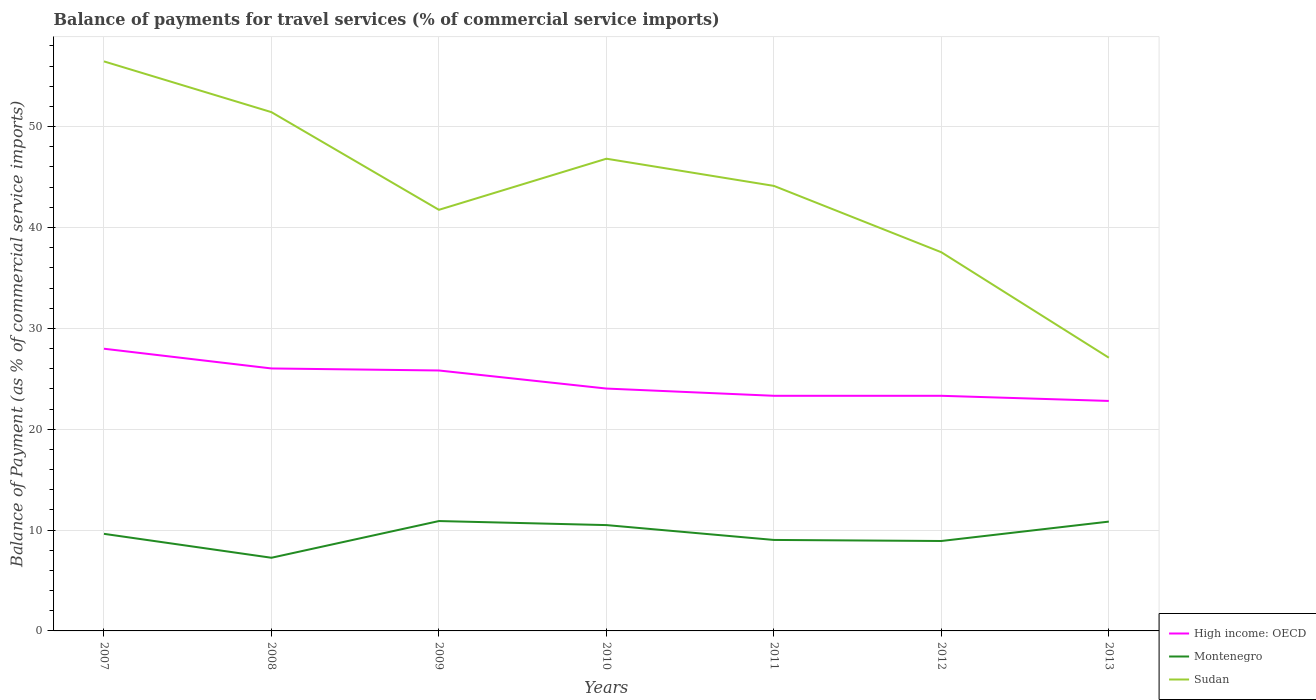How many different coloured lines are there?
Offer a very short reply. 3. Is the number of lines equal to the number of legend labels?
Your answer should be compact. Yes. Across all years, what is the maximum balance of payments for travel services in Sudan?
Provide a short and direct response. 27.09. In which year was the balance of payments for travel services in Sudan maximum?
Keep it short and to the point. 2013. What is the total balance of payments for travel services in Sudan in the graph?
Your answer should be compact. 19.73. What is the difference between the highest and the second highest balance of payments for travel services in High income: OECD?
Offer a terse response. 5.18. What is the difference between the highest and the lowest balance of payments for travel services in High income: OECD?
Provide a succinct answer. 3. Is the balance of payments for travel services in High income: OECD strictly greater than the balance of payments for travel services in Montenegro over the years?
Make the answer very short. No. How many years are there in the graph?
Your answer should be very brief. 7. Are the values on the major ticks of Y-axis written in scientific E-notation?
Provide a short and direct response. No. How many legend labels are there?
Provide a succinct answer. 3. What is the title of the graph?
Keep it short and to the point. Balance of payments for travel services (% of commercial service imports). Does "Vanuatu" appear as one of the legend labels in the graph?
Give a very brief answer. No. What is the label or title of the Y-axis?
Provide a short and direct response. Balance of Payment (as % of commercial service imports). What is the Balance of Payment (as % of commercial service imports) in High income: OECD in 2007?
Offer a very short reply. 27.98. What is the Balance of Payment (as % of commercial service imports) in Montenegro in 2007?
Offer a terse response. 9.63. What is the Balance of Payment (as % of commercial service imports) of Sudan in 2007?
Ensure brevity in your answer.  56.47. What is the Balance of Payment (as % of commercial service imports) of High income: OECD in 2008?
Provide a short and direct response. 26.02. What is the Balance of Payment (as % of commercial service imports) in Montenegro in 2008?
Offer a very short reply. 7.25. What is the Balance of Payment (as % of commercial service imports) in Sudan in 2008?
Offer a very short reply. 51.44. What is the Balance of Payment (as % of commercial service imports) of High income: OECD in 2009?
Offer a terse response. 25.82. What is the Balance of Payment (as % of commercial service imports) in Montenegro in 2009?
Make the answer very short. 10.89. What is the Balance of Payment (as % of commercial service imports) in Sudan in 2009?
Make the answer very short. 41.75. What is the Balance of Payment (as % of commercial service imports) of High income: OECD in 2010?
Give a very brief answer. 24.03. What is the Balance of Payment (as % of commercial service imports) of Montenegro in 2010?
Your answer should be very brief. 10.49. What is the Balance of Payment (as % of commercial service imports) of Sudan in 2010?
Ensure brevity in your answer.  46.82. What is the Balance of Payment (as % of commercial service imports) in High income: OECD in 2011?
Provide a short and direct response. 23.31. What is the Balance of Payment (as % of commercial service imports) in Montenegro in 2011?
Your answer should be compact. 9.02. What is the Balance of Payment (as % of commercial service imports) in Sudan in 2011?
Keep it short and to the point. 44.13. What is the Balance of Payment (as % of commercial service imports) of High income: OECD in 2012?
Make the answer very short. 23.31. What is the Balance of Payment (as % of commercial service imports) of Montenegro in 2012?
Your response must be concise. 8.92. What is the Balance of Payment (as % of commercial service imports) in Sudan in 2012?
Offer a terse response. 37.54. What is the Balance of Payment (as % of commercial service imports) of High income: OECD in 2013?
Your response must be concise. 22.8. What is the Balance of Payment (as % of commercial service imports) in Montenegro in 2013?
Offer a very short reply. 10.84. What is the Balance of Payment (as % of commercial service imports) of Sudan in 2013?
Your answer should be compact. 27.09. Across all years, what is the maximum Balance of Payment (as % of commercial service imports) of High income: OECD?
Provide a succinct answer. 27.98. Across all years, what is the maximum Balance of Payment (as % of commercial service imports) in Montenegro?
Your response must be concise. 10.89. Across all years, what is the maximum Balance of Payment (as % of commercial service imports) of Sudan?
Your response must be concise. 56.47. Across all years, what is the minimum Balance of Payment (as % of commercial service imports) in High income: OECD?
Offer a terse response. 22.8. Across all years, what is the minimum Balance of Payment (as % of commercial service imports) of Montenegro?
Ensure brevity in your answer.  7.25. Across all years, what is the minimum Balance of Payment (as % of commercial service imports) in Sudan?
Make the answer very short. 27.09. What is the total Balance of Payment (as % of commercial service imports) of High income: OECD in the graph?
Your answer should be very brief. 173.29. What is the total Balance of Payment (as % of commercial service imports) of Montenegro in the graph?
Your answer should be compact. 67.04. What is the total Balance of Payment (as % of commercial service imports) of Sudan in the graph?
Ensure brevity in your answer.  305.24. What is the difference between the Balance of Payment (as % of commercial service imports) in High income: OECD in 2007 and that in 2008?
Make the answer very short. 1.96. What is the difference between the Balance of Payment (as % of commercial service imports) of Montenegro in 2007 and that in 2008?
Your answer should be compact. 2.37. What is the difference between the Balance of Payment (as % of commercial service imports) of Sudan in 2007 and that in 2008?
Your answer should be compact. 5.03. What is the difference between the Balance of Payment (as % of commercial service imports) in High income: OECD in 2007 and that in 2009?
Your response must be concise. 2.16. What is the difference between the Balance of Payment (as % of commercial service imports) in Montenegro in 2007 and that in 2009?
Your response must be concise. -1.27. What is the difference between the Balance of Payment (as % of commercial service imports) in Sudan in 2007 and that in 2009?
Give a very brief answer. 14.72. What is the difference between the Balance of Payment (as % of commercial service imports) of High income: OECD in 2007 and that in 2010?
Offer a very short reply. 3.95. What is the difference between the Balance of Payment (as % of commercial service imports) in Montenegro in 2007 and that in 2010?
Your answer should be compact. -0.87. What is the difference between the Balance of Payment (as % of commercial service imports) of Sudan in 2007 and that in 2010?
Make the answer very short. 9.65. What is the difference between the Balance of Payment (as % of commercial service imports) in High income: OECD in 2007 and that in 2011?
Your response must be concise. 4.67. What is the difference between the Balance of Payment (as % of commercial service imports) in Montenegro in 2007 and that in 2011?
Make the answer very short. 0.61. What is the difference between the Balance of Payment (as % of commercial service imports) of Sudan in 2007 and that in 2011?
Offer a very short reply. 12.34. What is the difference between the Balance of Payment (as % of commercial service imports) of High income: OECD in 2007 and that in 2012?
Provide a succinct answer. 4.67. What is the difference between the Balance of Payment (as % of commercial service imports) of Montenegro in 2007 and that in 2012?
Offer a terse response. 0.71. What is the difference between the Balance of Payment (as % of commercial service imports) of Sudan in 2007 and that in 2012?
Ensure brevity in your answer.  18.92. What is the difference between the Balance of Payment (as % of commercial service imports) in High income: OECD in 2007 and that in 2013?
Provide a succinct answer. 5.18. What is the difference between the Balance of Payment (as % of commercial service imports) of Montenegro in 2007 and that in 2013?
Provide a succinct answer. -1.21. What is the difference between the Balance of Payment (as % of commercial service imports) of Sudan in 2007 and that in 2013?
Offer a terse response. 29.38. What is the difference between the Balance of Payment (as % of commercial service imports) in High income: OECD in 2008 and that in 2009?
Make the answer very short. 0.2. What is the difference between the Balance of Payment (as % of commercial service imports) in Montenegro in 2008 and that in 2009?
Your response must be concise. -3.64. What is the difference between the Balance of Payment (as % of commercial service imports) in Sudan in 2008 and that in 2009?
Offer a terse response. 9.68. What is the difference between the Balance of Payment (as % of commercial service imports) of High income: OECD in 2008 and that in 2010?
Your response must be concise. 1.99. What is the difference between the Balance of Payment (as % of commercial service imports) of Montenegro in 2008 and that in 2010?
Provide a succinct answer. -3.24. What is the difference between the Balance of Payment (as % of commercial service imports) of Sudan in 2008 and that in 2010?
Your answer should be compact. 4.62. What is the difference between the Balance of Payment (as % of commercial service imports) in High income: OECD in 2008 and that in 2011?
Provide a succinct answer. 2.71. What is the difference between the Balance of Payment (as % of commercial service imports) of Montenegro in 2008 and that in 2011?
Your answer should be compact. -1.77. What is the difference between the Balance of Payment (as % of commercial service imports) in Sudan in 2008 and that in 2011?
Your answer should be compact. 7.31. What is the difference between the Balance of Payment (as % of commercial service imports) in High income: OECD in 2008 and that in 2012?
Your response must be concise. 2.71. What is the difference between the Balance of Payment (as % of commercial service imports) in Montenegro in 2008 and that in 2012?
Offer a very short reply. -1.66. What is the difference between the Balance of Payment (as % of commercial service imports) of Sudan in 2008 and that in 2012?
Your answer should be very brief. 13.89. What is the difference between the Balance of Payment (as % of commercial service imports) in High income: OECD in 2008 and that in 2013?
Make the answer very short. 3.22. What is the difference between the Balance of Payment (as % of commercial service imports) in Montenegro in 2008 and that in 2013?
Ensure brevity in your answer.  -3.58. What is the difference between the Balance of Payment (as % of commercial service imports) of Sudan in 2008 and that in 2013?
Offer a very short reply. 24.35. What is the difference between the Balance of Payment (as % of commercial service imports) of High income: OECD in 2009 and that in 2010?
Provide a short and direct response. 1.79. What is the difference between the Balance of Payment (as % of commercial service imports) of Montenegro in 2009 and that in 2010?
Offer a very short reply. 0.4. What is the difference between the Balance of Payment (as % of commercial service imports) of Sudan in 2009 and that in 2010?
Keep it short and to the point. -5.07. What is the difference between the Balance of Payment (as % of commercial service imports) in High income: OECD in 2009 and that in 2011?
Give a very brief answer. 2.51. What is the difference between the Balance of Payment (as % of commercial service imports) in Montenegro in 2009 and that in 2011?
Make the answer very short. 1.87. What is the difference between the Balance of Payment (as % of commercial service imports) in Sudan in 2009 and that in 2011?
Provide a succinct answer. -2.37. What is the difference between the Balance of Payment (as % of commercial service imports) in High income: OECD in 2009 and that in 2012?
Keep it short and to the point. 2.51. What is the difference between the Balance of Payment (as % of commercial service imports) in Montenegro in 2009 and that in 2012?
Keep it short and to the point. 1.98. What is the difference between the Balance of Payment (as % of commercial service imports) in Sudan in 2009 and that in 2012?
Ensure brevity in your answer.  4.21. What is the difference between the Balance of Payment (as % of commercial service imports) of High income: OECD in 2009 and that in 2013?
Your response must be concise. 3.02. What is the difference between the Balance of Payment (as % of commercial service imports) in Montenegro in 2009 and that in 2013?
Offer a very short reply. 0.05. What is the difference between the Balance of Payment (as % of commercial service imports) in Sudan in 2009 and that in 2013?
Keep it short and to the point. 14.66. What is the difference between the Balance of Payment (as % of commercial service imports) of High income: OECD in 2010 and that in 2011?
Offer a terse response. 0.72. What is the difference between the Balance of Payment (as % of commercial service imports) in Montenegro in 2010 and that in 2011?
Provide a short and direct response. 1.47. What is the difference between the Balance of Payment (as % of commercial service imports) in Sudan in 2010 and that in 2011?
Give a very brief answer. 2.69. What is the difference between the Balance of Payment (as % of commercial service imports) in High income: OECD in 2010 and that in 2012?
Give a very brief answer. 0.72. What is the difference between the Balance of Payment (as % of commercial service imports) in Montenegro in 2010 and that in 2012?
Your answer should be compact. 1.58. What is the difference between the Balance of Payment (as % of commercial service imports) in Sudan in 2010 and that in 2012?
Your answer should be compact. 9.28. What is the difference between the Balance of Payment (as % of commercial service imports) of High income: OECD in 2010 and that in 2013?
Keep it short and to the point. 1.23. What is the difference between the Balance of Payment (as % of commercial service imports) of Montenegro in 2010 and that in 2013?
Your answer should be very brief. -0.35. What is the difference between the Balance of Payment (as % of commercial service imports) in Sudan in 2010 and that in 2013?
Your answer should be compact. 19.73. What is the difference between the Balance of Payment (as % of commercial service imports) in High income: OECD in 2011 and that in 2012?
Your response must be concise. 0. What is the difference between the Balance of Payment (as % of commercial service imports) of Montenegro in 2011 and that in 2012?
Make the answer very short. 0.1. What is the difference between the Balance of Payment (as % of commercial service imports) in Sudan in 2011 and that in 2012?
Offer a very short reply. 6.58. What is the difference between the Balance of Payment (as % of commercial service imports) in High income: OECD in 2011 and that in 2013?
Make the answer very short. 0.51. What is the difference between the Balance of Payment (as % of commercial service imports) of Montenegro in 2011 and that in 2013?
Offer a very short reply. -1.82. What is the difference between the Balance of Payment (as % of commercial service imports) of Sudan in 2011 and that in 2013?
Provide a succinct answer. 17.04. What is the difference between the Balance of Payment (as % of commercial service imports) of High income: OECD in 2012 and that in 2013?
Your response must be concise. 0.51. What is the difference between the Balance of Payment (as % of commercial service imports) of Montenegro in 2012 and that in 2013?
Provide a succinct answer. -1.92. What is the difference between the Balance of Payment (as % of commercial service imports) of Sudan in 2012 and that in 2013?
Ensure brevity in your answer.  10.45. What is the difference between the Balance of Payment (as % of commercial service imports) in High income: OECD in 2007 and the Balance of Payment (as % of commercial service imports) in Montenegro in 2008?
Your answer should be compact. 20.73. What is the difference between the Balance of Payment (as % of commercial service imports) of High income: OECD in 2007 and the Balance of Payment (as % of commercial service imports) of Sudan in 2008?
Offer a terse response. -23.46. What is the difference between the Balance of Payment (as % of commercial service imports) of Montenegro in 2007 and the Balance of Payment (as % of commercial service imports) of Sudan in 2008?
Offer a terse response. -41.81. What is the difference between the Balance of Payment (as % of commercial service imports) in High income: OECD in 2007 and the Balance of Payment (as % of commercial service imports) in Montenegro in 2009?
Provide a short and direct response. 17.09. What is the difference between the Balance of Payment (as % of commercial service imports) of High income: OECD in 2007 and the Balance of Payment (as % of commercial service imports) of Sudan in 2009?
Make the answer very short. -13.77. What is the difference between the Balance of Payment (as % of commercial service imports) in Montenegro in 2007 and the Balance of Payment (as % of commercial service imports) in Sudan in 2009?
Offer a very short reply. -32.13. What is the difference between the Balance of Payment (as % of commercial service imports) in High income: OECD in 2007 and the Balance of Payment (as % of commercial service imports) in Montenegro in 2010?
Give a very brief answer. 17.49. What is the difference between the Balance of Payment (as % of commercial service imports) of High income: OECD in 2007 and the Balance of Payment (as % of commercial service imports) of Sudan in 2010?
Provide a short and direct response. -18.84. What is the difference between the Balance of Payment (as % of commercial service imports) of Montenegro in 2007 and the Balance of Payment (as % of commercial service imports) of Sudan in 2010?
Your answer should be very brief. -37.19. What is the difference between the Balance of Payment (as % of commercial service imports) of High income: OECD in 2007 and the Balance of Payment (as % of commercial service imports) of Montenegro in 2011?
Keep it short and to the point. 18.96. What is the difference between the Balance of Payment (as % of commercial service imports) in High income: OECD in 2007 and the Balance of Payment (as % of commercial service imports) in Sudan in 2011?
Your answer should be very brief. -16.15. What is the difference between the Balance of Payment (as % of commercial service imports) of Montenegro in 2007 and the Balance of Payment (as % of commercial service imports) of Sudan in 2011?
Ensure brevity in your answer.  -34.5. What is the difference between the Balance of Payment (as % of commercial service imports) of High income: OECD in 2007 and the Balance of Payment (as % of commercial service imports) of Montenegro in 2012?
Your answer should be compact. 19.06. What is the difference between the Balance of Payment (as % of commercial service imports) in High income: OECD in 2007 and the Balance of Payment (as % of commercial service imports) in Sudan in 2012?
Provide a succinct answer. -9.56. What is the difference between the Balance of Payment (as % of commercial service imports) of Montenegro in 2007 and the Balance of Payment (as % of commercial service imports) of Sudan in 2012?
Your answer should be very brief. -27.92. What is the difference between the Balance of Payment (as % of commercial service imports) in High income: OECD in 2007 and the Balance of Payment (as % of commercial service imports) in Montenegro in 2013?
Make the answer very short. 17.14. What is the difference between the Balance of Payment (as % of commercial service imports) of High income: OECD in 2007 and the Balance of Payment (as % of commercial service imports) of Sudan in 2013?
Ensure brevity in your answer.  0.89. What is the difference between the Balance of Payment (as % of commercial service imports) of Montenegro in 2007 and the Balance of Payment (as % of commercial service imports) of Sudan in 2013?
Ensure brevity in your answer.  -17.46. What is the difference between the Balance of Payment (as % of commercial service imports) of High income: OECD in 2008 and the Balance of Payment (as % of commercial service imports) of Montenegro in 2009?
Your response must be concise. 15.13. What is the difference between the Balance of Payment (as % of commercial service imports) of High income: OECD in 2008 and the Balance of Payment (as % of commercial service imports) of Sudan in 2009?
Provide a succinct answer. -15.73. What is the difference between the Balance of Payment (as % of commercial service imports) in Montenegro in 2008 and the Balance of Payment (as % of commercial service imports) in Sudan in 2009?
Keep it short and to the point. -34.5. What is the difference between the Balance of Payment (as % of commercial service imports) in High income: OECD in 2008 and the Balance of Payment (as % of commercial service imports) in Montenegro in 2010?
Your answer should be very brief. 15.53. What is the difference between the Balance of Payment (as % of commercial service imports) in High income: OECD in 2008 and the Balance of Payment (as % of commercial service imports) in Sudan in 2010?
Your response must be concise. -20.8. What is the difference between the Balance of Payment (as % of commercial service imports) of Montenegro in 2008 and the Balance of Payment (as % of commercial service imports) of Sudan in 2010?
Offer a very short reply. -39.57. What is the difference between the Balance of Payment (as % of commercial service imports) of High income: OECD in 2008 and the Balance of Payment (as % of commercial service imports) of Montenegro in 2011?
Provide a succinct answer. 17. What is the difference between the Balance of Payment (as % of commercial service imports) in High income: OECD in 2008 and the Balance of Payment (as % of commercial service imports) in Sudan in 2011?
Your answer should be compact. -18.1. What is the difference between the Balance of Payment (as % of commercial service imports) of Montenegro in 2008 and the Balance of Payment (as % of commercial service imports) of Sudan in 2011?
Provide a short and direct response. -36.87. What is the difference between the Balance of Payment (as % of commercial service imports) in High income: OECD in 2008 and the Balance of Payment (as % of commercial service imports) in Montenegro in 2012?
Offer a very short reply. 17.11. What is the difference between the Balance of Payment (as % of commercial service imports) in High income: OECD in 2008 and the Balance of Payment (as % of commercial service imports) in Sudan in 2012?
Your answer should be very brief. -11.52. What is the difference between the Balance of Payment (as % of commercial service imports) of Montenegro in 2008 and the Balance of Payment (as % of commercial service imports) of Sudan in 2012?
Make the answer very short. -30.29. What is the difference between the Balance of Payment (as % of commercial service imports) in High income: OECD in 2008 and the Balance of Payment (as % of commercial service imports) in Montenegro in 2013?
Ensure brevity in your answer.  15.19. What is the difference between the Balance of Payment (as % of commercial service imports) in High income: OECD in 2008 and the Balance of Payment (as % of commercial service imports) in Sudan in 2013?
Your answer should be compact. -1.07. What is the difference between the Balance of Payment (as % of commercial service imports) of Montenegro in 2008 and the Balance of Payment (as % of commercial service imports) of Sudan in 2013?
Provide a short and direct response. -19.84. What is the difference between the Balance of Payment (as % of commercial service imports) of High income: OECD in 2009 and the Balance of Payment (as % of commercial service imports) of Montenegro in 2010?
Offer a terse response. 15.33. What is the difference between the Balance of Payment (as % of commercial service imports) of High income: OECD in 2009 and the Balance of Payment (as % of commercial service imports) of Sudan in 2010?
Ensure brevity in your answer.  -21. What is the difference between the Balance of Payment (as % of commercial service imports) in Montenegro in 2009 and the Balance of Payment (as % of commercial service imports) in Sudan in 2010?
Your answer should be compact. -35.93. What is the difference between the Balance of Payment (as % of commercial service imports) of High income: OECD in 2009 and the Balance of Payment (as % of commercial service imports) of Montenegro in 2011?
Ensure brevity in your answer.  16.8. What is the difference between the Balance of Payment (as % of commercial service imports) in High income: OECD in 2009 and the Balance of Payment (as % of commercial service imports) in Sudan in 2011?
Make the answer very short. -18.3. What is the difference between the Balance of Payment (as % of commercial service imports) in Montenegro in 2009 and the Balance of Payment (as % of commercial service imports) in Sudan in 2011?
Offer a very short reply. -33.23. What is the difference between the Balance of Payment (as % of commercial service imports) of High income: OECD in 2009 and the Balance of Payment (as % of commercial service imports) of Montenegro in 2012?
Keep it short and to the point. 16.91. What is the difference between the Balance of Payment (as % of commercial service imports) of High income: OECD in 2009 and the Balance of Payment (as % of commercial service imports) of Sudan in 2012?
Your response must be concise. -11.72. What is the difference between the Balance of Payment (as % of commercial service imports) in Montenegro in 2009 and the Balance of Payment (as % of commercial service imports) in Sudan in 2012?
Your response must be concise. -26.65. What is the difference between the Balance of Payment (as % of commercial service imports) in High income: OECD in 2009 and the Balance of Payment (as % of commercial service imports) in Montenegro in 2013?
Ensure brevity in your answer.  14.98. What is the difference between the Balance of Payment (as % of commercial service imports) in High income: OECD in 2009 and the Balance of Payment (as % of commercial service imports) in Sudan in 2013?
Give a very brief answer. -1.27. What is the difference between the Balance of Payment (as % of commercial service imports) in Montenegro in 2009 and the Balance of Payment (as % of commercial service imports) in Sudan in 2013?
Your answer should be very brief. -16.2. What is the difference between the Balance of Payment (as % of commercial service imports) in High income: OECD in 2010 and the Balance of Payment (as % of commercial service imports) in Montenegro in 2011?
Offer a very short reply. 15.01. What is the difference between the Balance of Payment (as % of commercial service imports) in High income: OECD in 2010 and the Balance of Payment (as % of commercial service imports) in Sudan in 2011?
Offer a very short reply. -20.09. What is the difference between the Balance of Payment (as % of commercial service imports) in Montenegro in 2010 and the Balance of Payment (as % of commercial service imports) in Sudan in 2011?
Ensure brevity in your answer.  -33.63. What is the difference between the Balance of Payment (as % of commercial service imports) of High income: OECD in 2010 and the Balance of Payment (as % of commercial service imports) of Montenegro in 2012?
Your answer should be very brief. 15.11. What is the difference between the Balance of Payment (as % of commercial service imports) of High income: OECD in 2010 and the Balance of Payment (as % of commercial service imports) of Sudan in 2012?
Ensure brevity in your answer.  -13.51. What is the difference between the Balance of Payment (as % of commercial service imports) in Montenegro in 2010 and the Balance of Payment (as % of commercial service imports) in Sudan in 2012?
Your response must be concise. -27.05. What is the difference between the Balance of Payment (as % of commercial service imports) of High income: OECD in 2010 and the Balance of Payment (as % of commercial service imports) of Montenegro in 2013?
Make the answer very short. 13.19. What is the difference between the Balance of Payment (as % of commercial service imports) of High income: OECD in 2010 and the Balance of Payment (as % of commercial service imports) of Sudan in 2013?
Give a very brief answer. -3.06. What is the difference between the Balance of Payment (as % of commercial service imports) of Montenegro in 2010 and the Balance of Payment (as % of commercial service imports) of Sudan in 2013?
Offer a very short reply. -16.6. What is the difference between the Balance of Payment (as % of commercial service imports) in High income: OECD in 2011 and the Balance of Payment (as % of commercial service imports) in Montenegro in 2012?
Make the answer very short. 14.4. What is the difference between the Balance of Payment (as % of commercial service imports) of High income: OECD in 2011 and the Balance of Payment (as % of commercial service imports) of Sudan in 2012?
Provide a succinct answer. -14.23. What is the difference between the Balance of Payment (as % of commercial service imports) of Montenegro in 2011 and the Balance of Payment (as % of commercial service imports) of Sudan in 2012?
Ensure brevity in your answer.  -28.52. What is the difference between the Balance of Payment (as % of commercial service imports) in High income: OECD in 2011 and the Balance of Payment (as % of commercial service imports) in Montenegro in 2013?
Ensure brevity in your answer.  12.47. What is the difference between the Balance of Payment (as % of commercial service imports) in High income: OECD in 2011 and the Balance of Payment (as % of commercial service imports) in Sudan in 2013?
Your response must be concise. -3.78. What is the difference between the Balance of Payment (as % of commercial service imports) of Montenegro in 2011 and the Balance of Payment (as % of commercial service imports) of Sudan in 2013?
Make the answer very short. -18.07. What is the difference between the Balance of Payment (as % of commercial service imports) in High income: OECD in 2012 and the Balance of Payment (as % of commercial service imports) in Montenegro in 2013?
Keep it short and to the point. 12.47. What is the difference between the Balance of Payment (as % of commercial service imports) in High income: OECD in 2012 and the Balance of Payment (as % of commercial service imports) in Sudan in 2013?
Give a very brief answer. -3.78. What is the difference between the Balance of Payment (as % of commercial service imports) of Montenegro in 2012 and the Balance of Payment (as % of commercial service imports) of Sudan in 2013?
Give a very brief answer. -18.17. What is the average Balance of Payment (as % of commercial service imports) of High income: OECD per year?
Give a very brief answer. 24.76. What is the average Balance of Payment (as % of commercial service imports) in Montenegro per year?
Your response must be concise. 9.58. What is the average Balance of Payment (as % of commercial service imports) in Sudan per year?
Provide a succinct answer. 43.61. In the year 2007, what is the difference between the Balance of Payment (as % of commercial service imports) in High income: OECD and Balance of Payment (as % of commercial service imports) in Montenegro?
Give a very brief answer. 18.35. In the year 2007, what is the difference between the Balance of Payment (as % of commercial service imports) in High income: OECD and Balance of Payment (as % of commercial service imports) in Sudan?
Provide a short and direct response. -28.49. In the year 2007, what is the difference between the Balance of Payment (as % of commercial service imports) of Montenegro and Balance of Payment (as % of commercial service imports) of Sudan?
Make the answer very short. -46.84. In the year 2008, what is the difference between the Balance of Payment (as % of commercial service imports) of High income: OECD and Balance of Payment (as % of commercial service imports) of Montenegro?
Give a very brief answer. 18.77. In the year 2008, what is the difference between the Balance of Payment (as % of commercial service imports) in High income: OECD and Balance of Payment (as % of commercial service imports) in Sudan?
Keep it short and to the point. -25.41. In the year 2008, what is the difference between the Balance of Payment (as % of commercial service imports) in Montenegro and Balance of Payment (as % of commercial service imports) in Sudan?
Your response must be concise. -44.18. In the year 2009, what is the difference between the Balance of Payment (as % of commercial service imports) in High income: OECD and Balance of Payment (as % of commercial service imports) in Montenegro?
Provide a succinct answer. 14.93. In the year 2009, what is the difference between the Balance of Payment (as % of commercial service imports) of High income: OECD and Balance of Payment (as % of commercial service imports) of Sudan?
Offer a terse response. -15.93. In the year 2009, what is the difference between the Balance of Payment (as % of commercial service imports) in Montenegro and Balance of Payment (as % of commercial service imports) in Sudan?
Give a very brief answer. -30.86. In the year 2010, what is the difference between the Balance of Payment (as % of commercial service imports) in High income: OECD and Balance of Payment (as % of commercial service imports) in Montenegro?
Offer a terse response. 13.54. In the year 2010, what is the difference between the Balance of Payment (as % of commercial service imports) in High income: OECD and Balance of Payment (as % of commercial service imports) in Sudan?
Keep it short and to the point. -22.79. In the year 2010, what is the difference between the Balance of Payment (as % of commercial service imports) of Montenegro and Balance of Payment (as % of commercial service imports) of Sudan?
Ensure brevity in your answer.  -36.33. In the year 2011, what is the difference between the Balance of Payment (as % of commercial service imports) in High income: OECD and Balance of Payment (as % of commercial service imports) in Montenegro?
Your answer should be very brief. 14.29. In the year 2011, what is the difference between the Balance of Payment (as % of commercial service imports) in High income: OECD and Balance of Payment (as % of commercial service imports) in Sudan?
Offer a terse response. -20.81. In the year 2011, what is the difference between the Balance of Payment (as % of commercial service imports) in Montenegro and Balance of Payment (as % of commercial service imports) in Sudan?
Keep it short and to the point. -35.1. In the year 2012, what is the difference between the Balance of Payment (as % of commercial service imports) of High income: OECD and Balance of Payment (as % of commercial service imports) of Montenegro?
Give a very brief answer. 14.4. In the year 2012, what is the difference between the Balance of Payment (as % of commercial service imports) in High income: OECD and Balance of Payment (as % of commercial service imports) in Sudan?
Your answer should be compact. -14.23. In the year 2012, what is the difference between the Balance of Payment (as % of commercial service imports) in Montenegro and Balance of Payment (as % of commercial service imports) in Sudan?
Offer a very short reply. -28.63. In the year 2013, what is the difference between the Balance of Payment (as % of commercial service imports) of High income: OECD and Balance of Payment (as % of commercial service imports) of Montenegro?
Your answer should be compact. 11.96. In the year 2013, what is the difference between the Balance of Payment (as % of commercial service imports) of High income: OECD and Balance of Payment (as % of commercial service imports) of Sudan?
Provide a short and direct response. -4.29. In the year 2013, what is the difference between the Balance of Payment (as % of commercial service imports) of Montenegro and Balance of Payment (as % of commercial service imports) of Sudan?
Provide a succinct answer. -16.25. What is the ratio of the Balance of Payment (as % of commercial service imports) of High income: OECD in 2007 to that in 2008?
Offer a very short reply. 1.08. What is the ratio of the Balance of Payment (as % of commercial service imports) in Montenegro in 2007 to that in 2008?
Your response must be concise. 1.33. What is the ratio of the Balance of Payment (as % of commercial service imports) of Sudan in 2007 to that in 2008?
Provide a succinct answer. 1.1. What is the ratio of the Balance of Payment (as % of commercial service imports) in High income: OECD in 2007 to that in 2009?
Provide a succinct answer. 1.08. What is the ratio of the Balance of Payment (as % of commercial service imports) in Montenegro in 2007 to that in 2009?
Offer a terse response. 0.88. What is the ratio of the Balance of Payment (as % of commercial service imports) in Sudan in 2007 to that in 2009?
Provide a succinct answer. 1.35. What is the ratio of the Balance of Payment (as % of commercial service imports) in High income: OECD in 2007 to that in 2010?
Your response must be concise. 1.16. What is the ratio of the Balance of Payment (as % of commercial service imports) in Montenegro in 2007 to that in 2010?
Provide a succinct answer. 0.92. What is the ratio of the Balance of Payment (as % of commercial service imports) in Sudan in 2007 to that in 2010?
Give a very brief answer. 1.21. What is the ratio of the Balance of Payment (as % of commercial service imports) of High income: OECD in 2007 to that in 2011?
Your answer should be compact. 1.2. What is the ratio of the Balance of Payment (as % of commercial service imports) of Montenegro in 2007 to that in 2011?
Give a very brief answer. 1.07. What is the ratio of the Balance of Payment (as % of commercial service imports) in Sudan in 2007 to that in 2011?
Ensure brevity in your answer.  1.28. What is the ratio of the Balance of Payment (as % of commercial service imports) of High income: OECD in 2007 to that in 2012?
Make the answer very short. 1.2. What is the ratio of the Balance of Payment (as % of commercial service imports) of Montenegro in 2007 to that in 2012?
Provide a short and direct response. 1.08. What is the ratio of the Balance of Payment (as % of commercial service imports) in Sudan in 2007 to that in 2012?
Give a very brief answer. 1.5. What is the ratio of the Balance of Payment (as % of commercial service imports) in High income: OECD in 2007 to that in 2013?
Keep it short and to the point. 1.23. What is the ratio of the Balance of Payment (as % of commercial service imports) in Montenegro in 2007 to that in 2013?
Your answer should be compact. 0.89. What is the ratio of the Balance of Payment (as % of commercial service imports) of Sudan in 2007 to that in 2013?
Give a very brief answer. 2.08. What is the ratio of the Balance of Payment (as % of commercial service imports) of Montenegro in 2008 to that in 2009?
Your answer should be very brief. 0.67. What is the ratio of the Balance of Payment (as % of commercial service imports) in Sudan in 2008 to that in 2009?
Ensure brevity in your answer.  1.23. What is the ratio of the Balance of Payment (as % of commercial service imports) of High income: OECD in 2008 to that in 2010?
Give a very brief answer. 1.08. What is the ratio of the Balance of Payment (as % of commercial service imports) in Montenegro in 2008 to that in 2010?
Give a very brief answer. 0.69. What is the ratio of the Balance of Payment (as % of commercial service imports) in Sudan in 2008 to that in 2010?
Offer a terse response. 1.1. What is the ratio of the Balance of Payment (as % of commercial service imports) in High income: OECD in 2008 to that in 2011?
Your response must be concise. 1.12. What is the ratio of the Balance of Payment (as % of commercial service imports) in Montenegro in 2008 to that in 2011?
Keep it short and to the point. 0.8. What is the ratio of the Balance of Payment (as % of commercial service imports) of Sudan in 2008 to that in 2011?
Make the answer very short. 1.17. What is the ratio of the Balance of Payment (as % of commercial service imports) in High income: OECD in 2008 to that in 2012?
Provide a short and direct response. 1.12. What is the ratio of the Balance of Payment (as % of commercial service imports) in Montenegro in 2008 to that in 2012?
Your answer should be very brief. 0.81. What is the ratio of the Balance of Payment (as % of commercial service imports) in Sudan in 2008 to that in 2012?
Your answer should be very brief. 1.37. What is the ratio of the Balance of Payment (as % of commercial service imports) of High income: OECD in 2008 to that in 2013?
Your answer should be compact. 1.14. What is the ratio of the Balance of Payment (as % of commercial service imports) in Montenegro in 2008 to that in 2013?
Provide a succinct answer. 0.67. What is the ratio of the Balance of Payment (as % of commercial service imports) of Sudan in 2008 to that in 2013?
Offer a very short reply. 1.9. What is the ratio of the Balance of Payment (as % of commercial service imports) in High income: OECD in 2009 to that in 2010?
Your answer should be compact. 1.07. What is the ratio of the Balance of Payment (as % of commercial service imports) of Montenegro in 2009 to that in 2010?
Provide a short and direct response. 1.04. What is the ratio of the Balance of Payment (as % of commercial service imports) of Sudan in 2009 to that in 2010?
Make the answer very short. 0.89. What is the ratio of the Balance of Payment (as % of commercial service imports) of High income: OECD in 2009 to that in 2011?
Make the answer very short. 1.11. What is the ratio of the Balance of Payment (as % of commercial service imports) in Montenegro in 2009 to that in 2011?
Offer a very short reply. 1.21. What is the ratio of the Balance of Payment (as % of commercial service imports) in Sudan in 2009 to that in 2011?
Your answer should be compact. 0.95. What is the ratio of the Balance of Payment (as % of commercial service imports) in High income: OECD in 2009 to that in 2012?
Give a very brief answer. 1.11. What is the ratio of the Balance of Payment (as % of commercial service imports) of Montenegro in 2009 to that in 2012?
Your answer should be compact. 1.22. What is the ratio of the Balance of Payment (as % of commercial service imports) in Sudan in 2009 to that in 2012?
Make the answer very short. 1.11. What is the ratio of the Balance of Payment (as % of commercial service imports) in High income: OECD in 2009 to that in 2013?
Make the answer very short. 1.13. What is the ratio of the Balance of Payment (as % of commercial service imports) of Montenegro in 2009 to that in 2013?
Your answer should be very brief. 1. What is the ratio of the Balance of Payment (as % of commercial service imports) in Sudan in 2009 to that in 2013?
Your answer should be compact. 1.54. What is the ratio of the Balance of Payment (as % of commercial service imports) in High income: OECD in 2010 to that in 2011?
Your response must be concise. 1.03. What is the ratio of the Balance of Payment (as % of commercial service imports) of Montenegro in 2010 to that in 2011?
Provide a short and direct response. 1.16. What is the ratio of the Balance of Payment (as % of commercial service imports) in Sudan in 2010 to that in 2011?
Your response must be concise. 1.06. What is the ratio of the Balance of Payment (as % of commercial service imports) of High income: OECD in 2010 to that in 2012?
Provide a succinct answer. 1.03. What is the ratio of the Balance of Payment (as % of commercial service imports) of Montenegro in 2010 to that in 2012?
Your answer should be very brief. 1.18. What is the ratio of the Balance of Payment (as % of commercial service imports) of Sudan in 2010 to that in 2012?
Offer a very short reply. 1.25. What is the ratio of the Balance of Payment (as % of commercial service imports) of High income: OECD in 2010 to that in 2013?
Offer a very short reply. 1.05. What is the ratio of the Balance of Payment (as % of commercial service imports) in Montenegro in 2010 to that in 2013?
Keep it short and to the point. 0.97. What is the ratio of the Balance of Payment (as % of commercial service imports) of Sudan in 2010 to that in 2013?
Make the answer very short. 1.73. What is the ratio of the Balance of Payment (as % of commercial service imports) in Montenegro in 2011 to that in 2012?
Give a very brief answer. 1.01. What is the ratio of the Balance of Payment (as % of commercial service imports) of Sudan in 2011 to that in 2012?
Your answer should be compact. 1.18. What is the ratio of the Balance of Payment (as % of commercial service imports) of High income: OECD in 2011 to that in 2013?
Offer a very short reply. 1.02. What is the ratio of the Balance of Payment (as % of commercial service imports) of Montenegro in 2011 to that in 2013?
Your response must be concise. 0.83. What is the ratio of the Balance of Payment (as % of commercial service imports) in Sudan in 2011 to that in 2013?
Offer a very short reply. 1.63. What is the ratio of the Balance of Payment (as % of commercial service imports) in High income: OECD in 2012 to that in 2013?
Your answer should be very brief. 1.02. What is the ratio of the Balance of Payment (as % of commercial service imports) of Montenegro in 2012 to that in 2013?
Your answer should be compact. 0.82. What is the ratio of the Balance of Payment (as % of commercial service imports) in Sudan in 2012 to that in 2013?
Give a very brief answer. 1.39. What is the difference between the highest and the second highest Balance of Payment (as % of commercial service imports) of High income: OECD?
Provide a succinct answer. 1.96. What is the difference between the highest and the second highest Balance of Payment (as % of commercial service imports) of Montenegro?
Give a very brief answer. 0.05. What is the difference between the highest and the second highest Balance of Payment (as % of commercial service imports) in Sudan?
Your response must be concise. 5.03. What is the difference between the highest and the lowest Balance of Payment (as % of commercial service imports) in High income: OECD?
Give a very brief answer. 5.18. What is the difference between the highest and the lowest Balance of Payment (as % of commercial service imports) in Montenegro?
Make the answer very short. 3.64. What is the difference between the highest and the lowest Balance of Payment (as % of commercial service imports) of Sudan?
Your response must be concise. 29.38. 